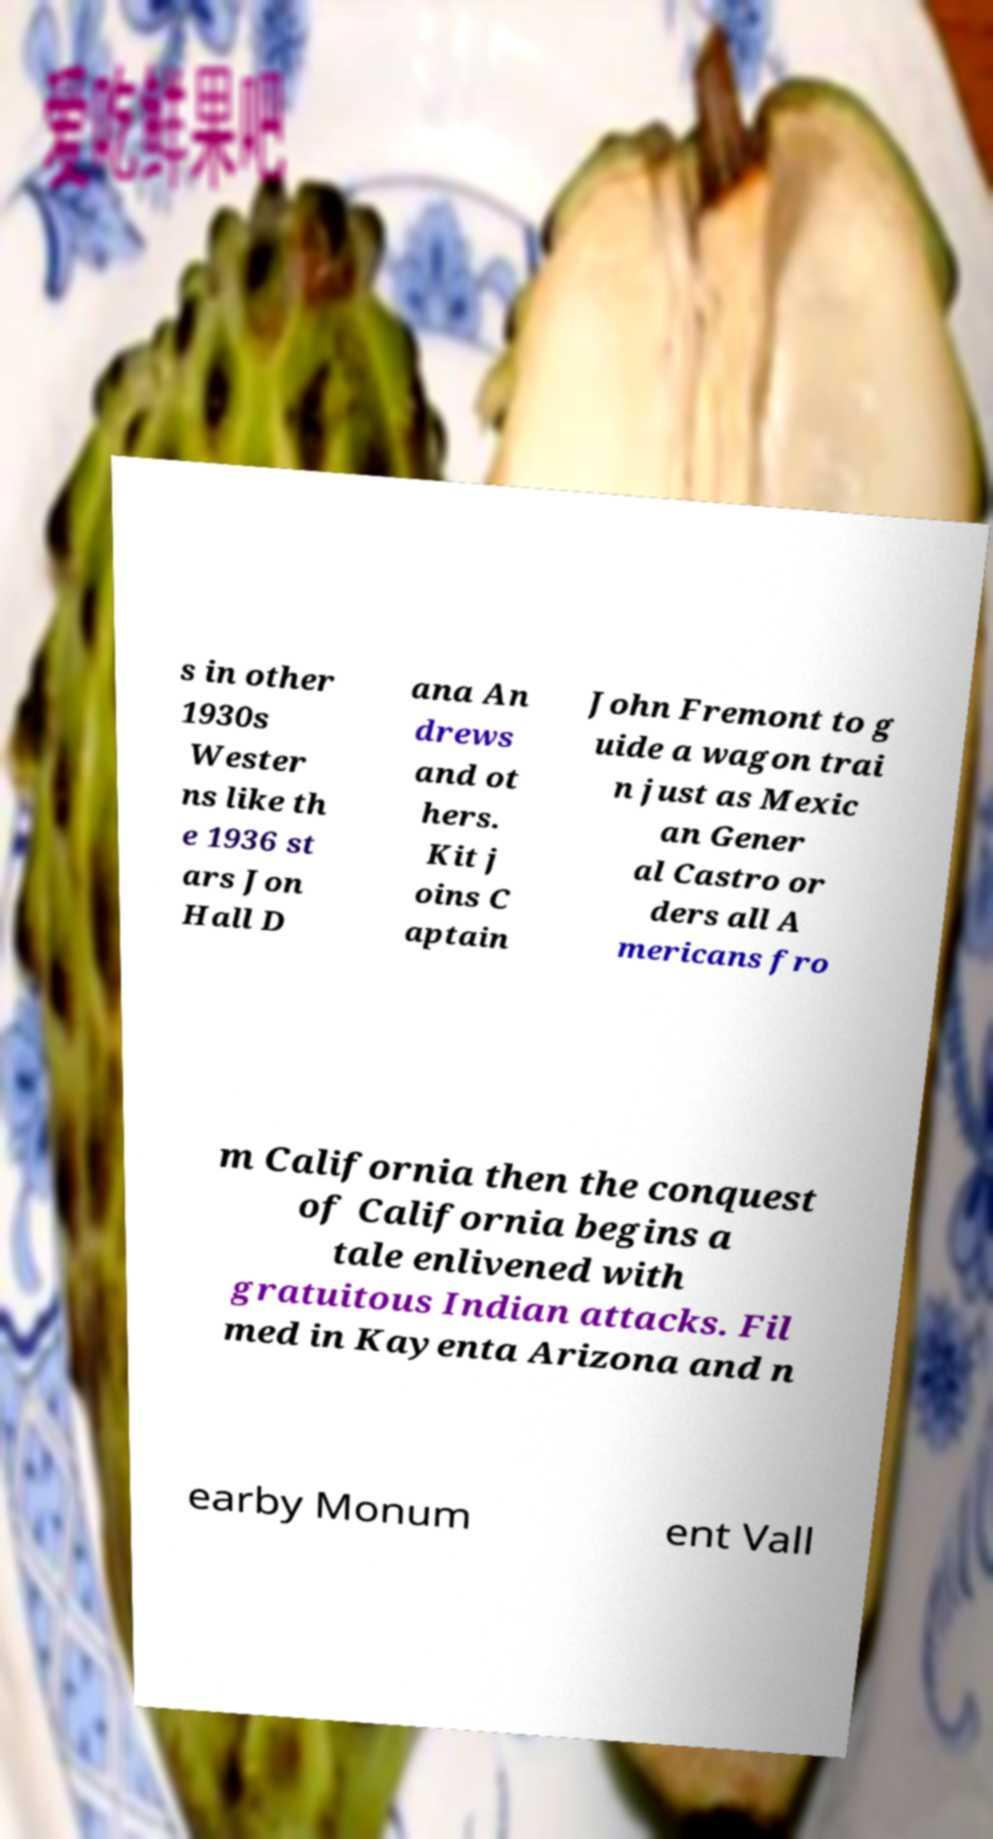There's text embedded in this image that I need extracted. Can you transcribe it verbatim? s in other 1930s Wester ns like th e 1936 st ars Jon Hall D ana An drews and ot hers. Kit j oins C aptain John Fremont to g uide a wagon trai n just as Mexic an Gener al Castro or ders all A mericans fro m California then the conquest of California begins a tale enlivened with gratuitous Indian attacks. Fil med in Kayenta Arizona and n earby Monum ent Vall 